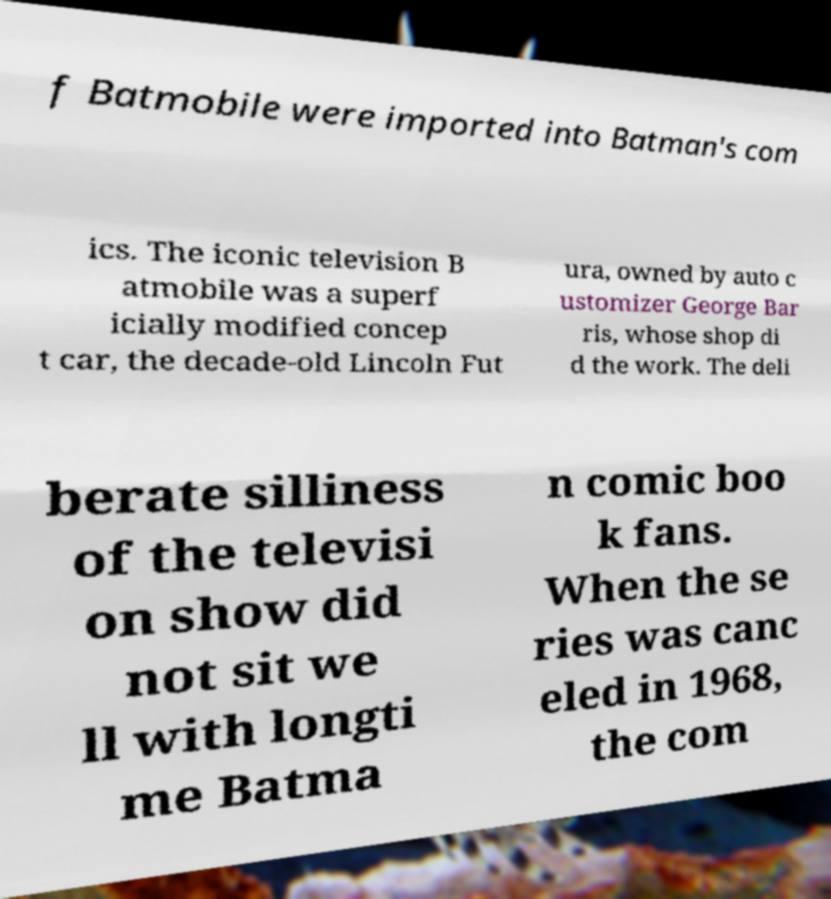Could you extract and type out the text from this image? f Batmobile were imported into Batman's com ics. The iconic television B atmobile was a superf icially modified concep t car, the decade-old Lincoln Fut ura, owned by auto c ustomizer George Bar ris, whose shop di d the work. The deli berate silliness of the televisi on show did not sit we ll with longti me Batma n comic boo k fans. When the se ries was canc eled in 1968, the com 